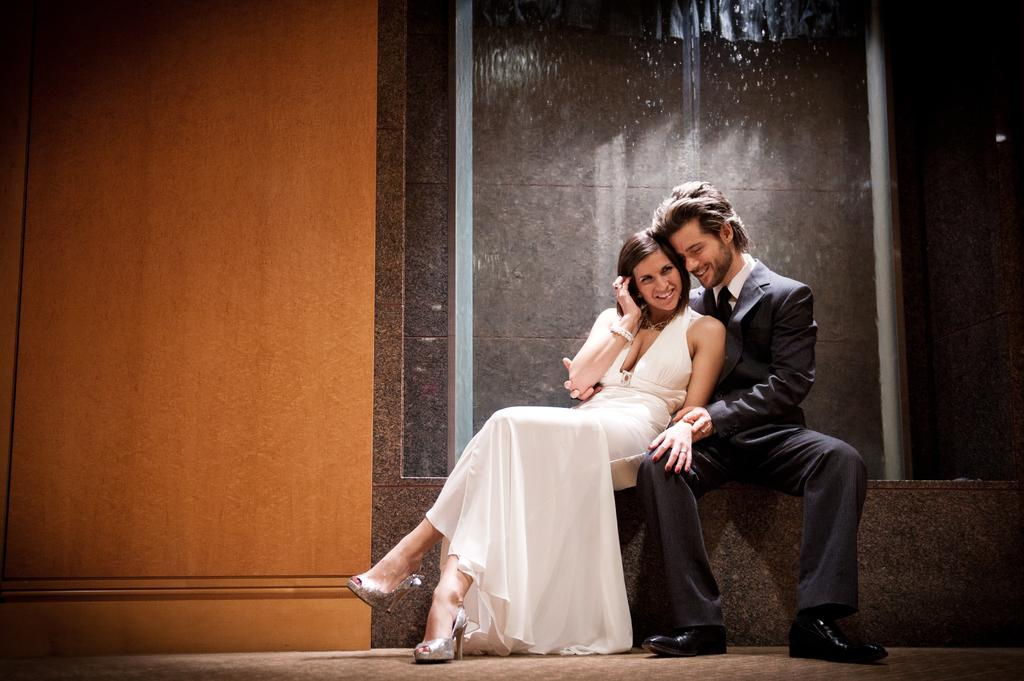How many people are in the image? There are two people in the image. What are the people in the image doing? Both people are sitting. What expressions do the people have in the image? Both people are smiling. What is the woman wearing in the image? The woman is wearing a white dress. What is the man wearing in the image? The man is wearing a black suit. What can be seen in the background of the image? There is a wall in the background of the image. What type of trucks can be seen transporting silver in the image? There are no trucks or silver present in the image; it features two people sitting and smiling. 